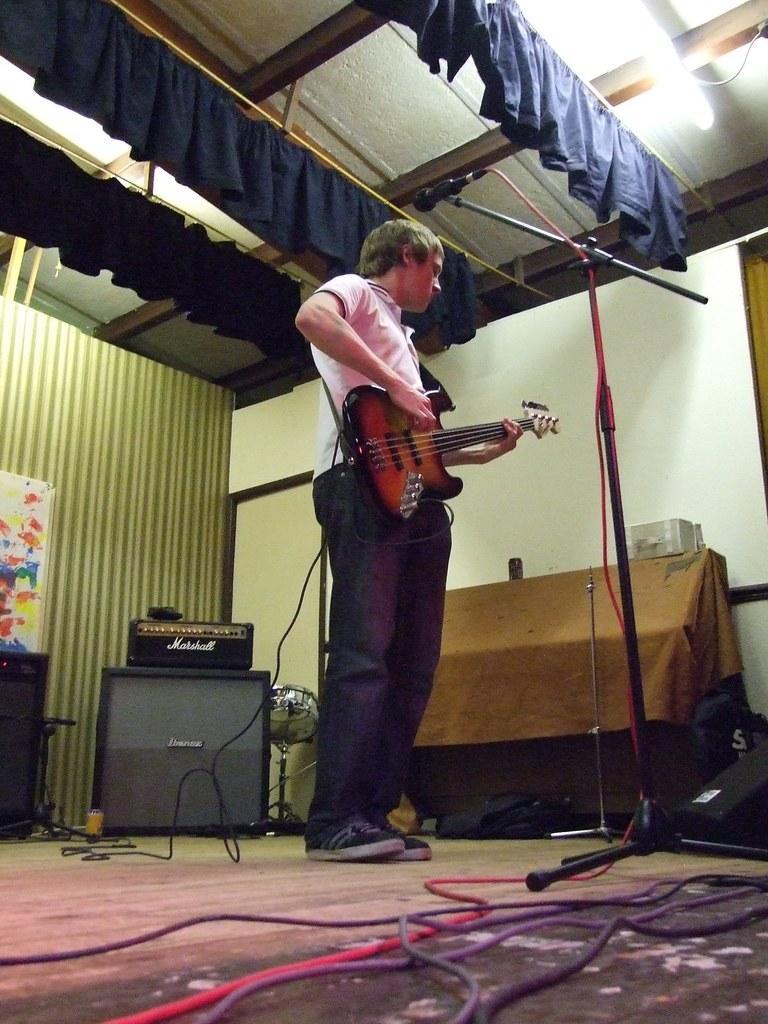Could you give a brief overview of what you see in this image? A man is playing guitar with a mic in front of him. 